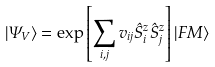Convert formula to latex. <formula><loc_0><loc_0><loc_500><loc_500>| \Psi _ { V } \rangle = \exp \left [ \sum _ { i , j } v _ { i j } \hat { S } _ { i } ^ { z } \hat { S } _ { j } ^ { z } \right ] | F M \rangle</formula> 